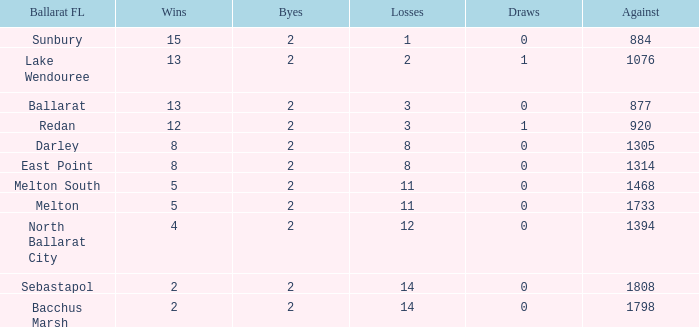For a ballarat fl team in melton south, how many losses have they experienced with an against value over 1468? 0.0. Could you help me parse every detail presented in this table? {'header': ['Ballarat FL', 'Wins', 'Byes', 'Losses', 'Draws', 'Against'], 'rows': [['Sunbury', '15', '2', '1', '0', '884'], ['Lake Wendouree', '13', '2', '2', '1', '1076'], ['Ballarat', '13', '2', '3', '0', '877'], ['Redan', '12', '2', '3', '1', '920'], ['Darley', '8', '2', '8', '0', '1305'], ['East Point', '8', '2', '8', '0', '1314'], ['Melton South', '5', '2', '11', '0', '1468'], ['Melton', '5', '2', '11', '0', '1733'], ['North Ballarat City', '4', '2', '12', '0', '1394'], ['Sebastapol', '2', '2', '14', '0', '1808'], ['Bacchus Marsh', '2', '2', '14', '0', '1798']]} 